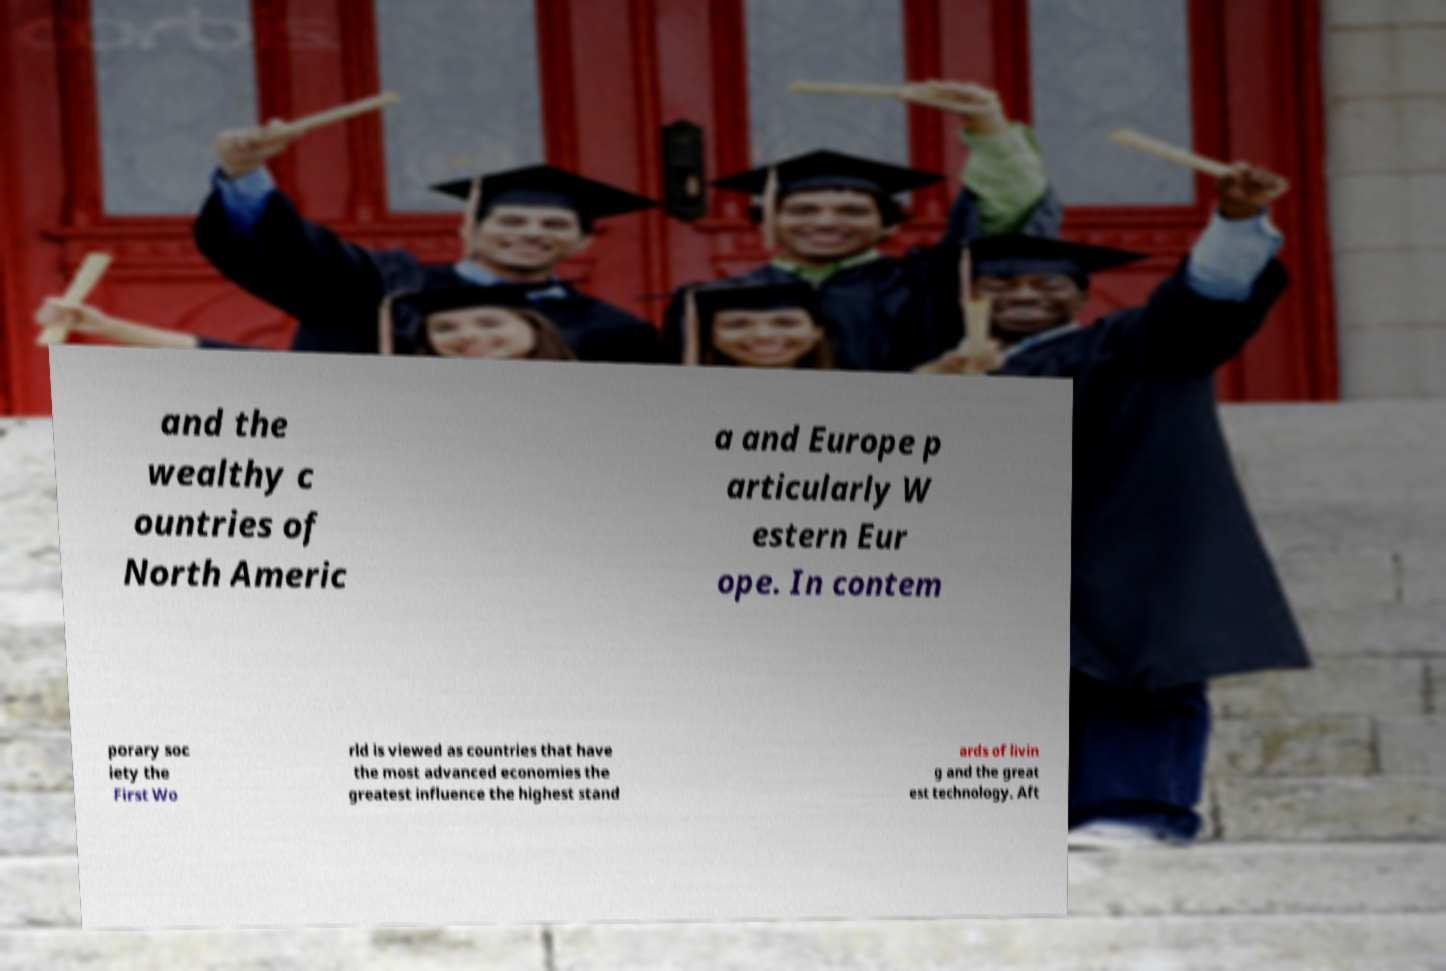There's text embedded in this image that I need extracted. Can you transcribe it verbatim? and the wealthy c ountries of North Americ a and Europe p articularly W estern Eur ope. In contem porary soc iety the First Wo rld is viewed as countries that have the most advanced economies the greatest influence the highest stand ards of livin g and the great est technology. Aft 